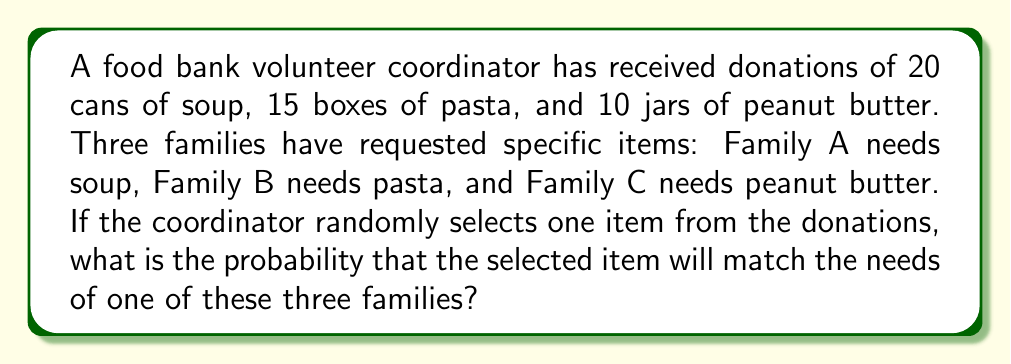Provide a solution to this math problem. To solve this problem, we need to follow these steps:

1. Calculate the total number of items:
   $$ \text{Total items} = 20 + 15 + 10 = 45 $$

2. Identify the favorable outcomes:
   - Selecting soup (matches Family A)
   - Selecting pasta (matches Family B)
   - Selecting peanut butter (matches Family C)

3. Calculate the probability of each favorable outcome:
   $$ P(\text{Soup}) = \frac{20}{45} $$
   $$ P(\text{Pasta}) = \frac{15}{45} $$
   $$ P(\text{Peanut Butter}) = \frac{10}{45} $$

4. Sum the probabilities of all favorable outcomes:
   $$ P(\text{Matching}) = P(\text{Soup}) + P(\text{Pasta}) + P(\text{Peanut Butter}) $$
   $$ P(\text{Matching}) = \frac{20}{45} + \frac{15}{45} + \frac{10}{45} $$
   $$ P(\text{Matching}) = \frac{45}{45} = 1 $$

Therefore, the probability of randomly selecting an item that matches one of the three families' needs is 1, or 100%.
Answer: The probability is 1 or 100%. 